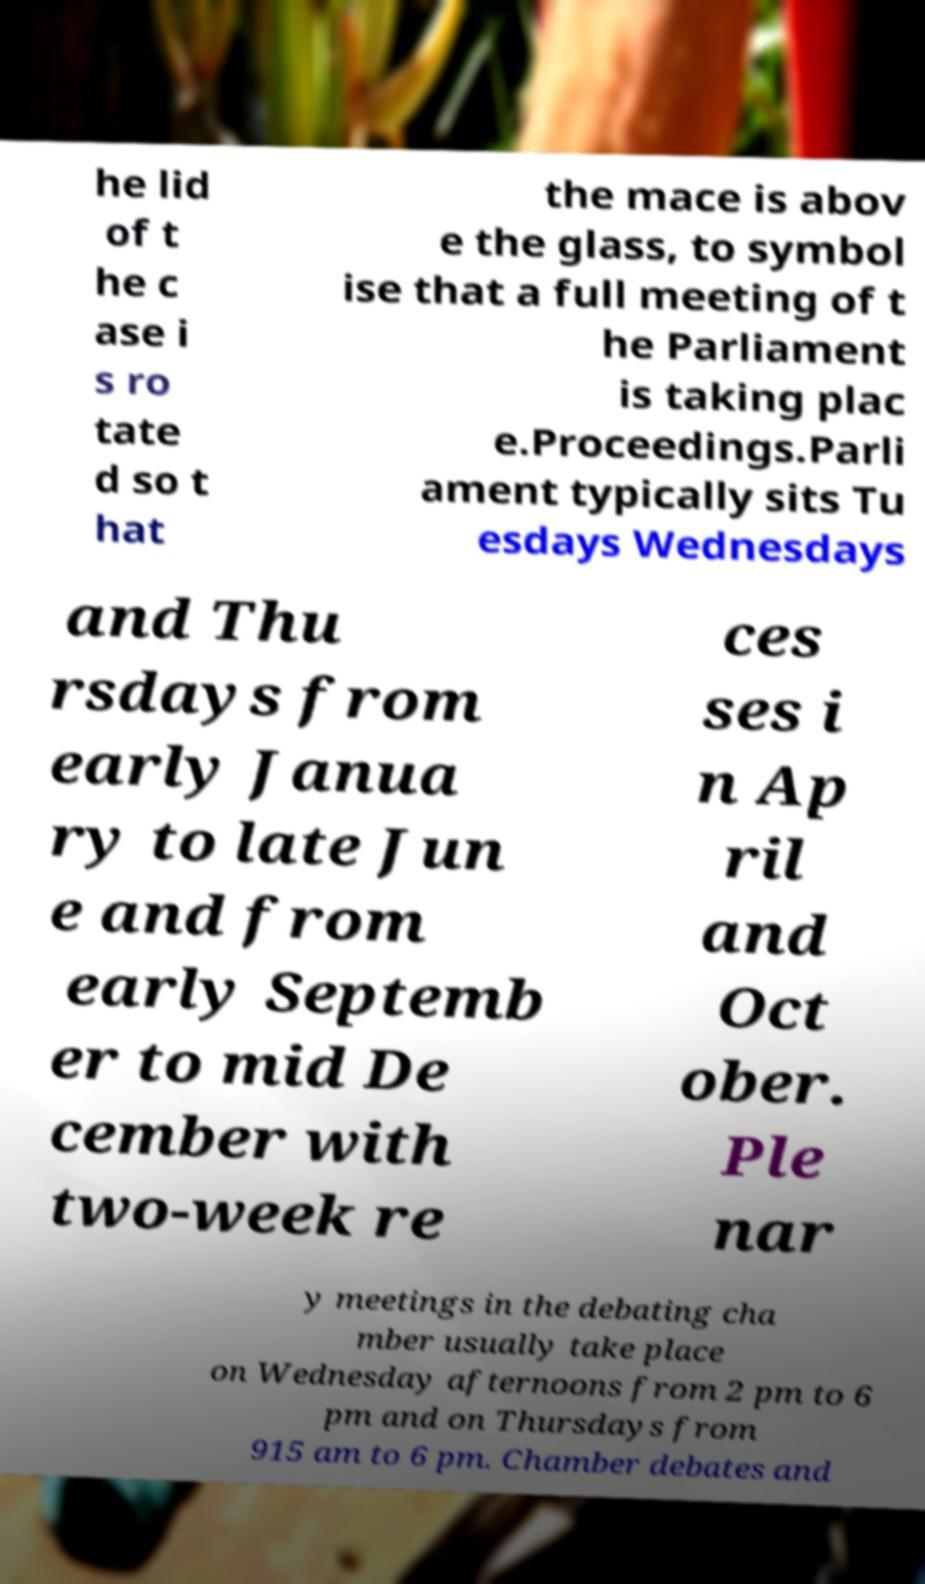For documentation purposes, I need the text within this image transcribed. Could you provide that? he lid of t he c ase i s ro tate d so t hat the mace is abov e the glass, to symbol ise that a full meeting of t he Parliament is taking plac e.Proceedings.Parli ament typically sits Tu esdays Wednesdays and Thu rsdays from early Janua ry to late Jun e and from early Septemb er to mid De cember with two-week re ces ses i n Ap ril and Oct ober. Ple nar y meetings in the debating cha mber usually take place on Wednesday afternoons from 2 pm to 6 pm and on Thursdays from 915 am to 6 pm. Chamber debates and 